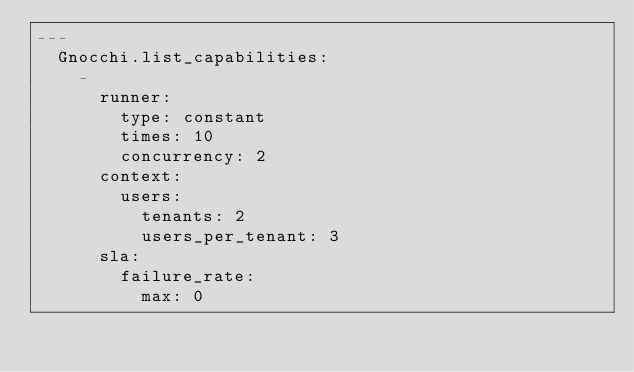Convert code to text. <code><loc_0><loc_0><loc_500><loc_500><_YAML_>---
  Gnocchi.list_capabilities:
    -
      runner:
        type: constant
        times: 10
        concurrency: 2
      context:
        users:
          tenants: 2
          users_per_tenant: 3
      sla:
        failure_rate:
          max: 0
</code> 